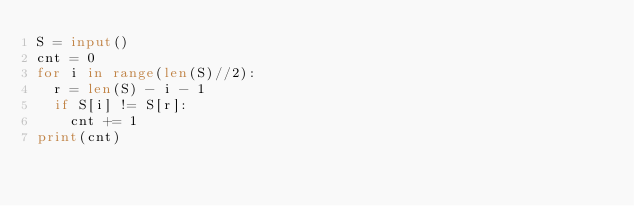<code> <loc_0><loc_0><loc_500><loc_500><_Python_>S = input()
cnt = 0
for i in range(len(S)//2):
  r = len(S) - i - 1
  if S[i] != S[r]:
    cnt += 1
print(cnt)</code> 